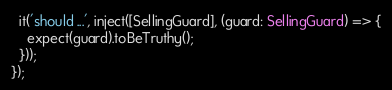Convert code to text. <code><loc_0><loc_0><loc_500><loc_500><_TypeScript_>  it('should ...', inject([SellingGuard], (guard: SellingGuard) => {
    expect(guard).toBeTruthy();
  }));
});
</code> 